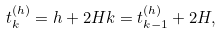<formula> <loc_0><loc_0><loc_500><loc_500>t _ { k } ^ { ( h ) } = h + 2 H k = t _ { k - 1 } ^ { ( h ) } + 2 H ,</formula> 